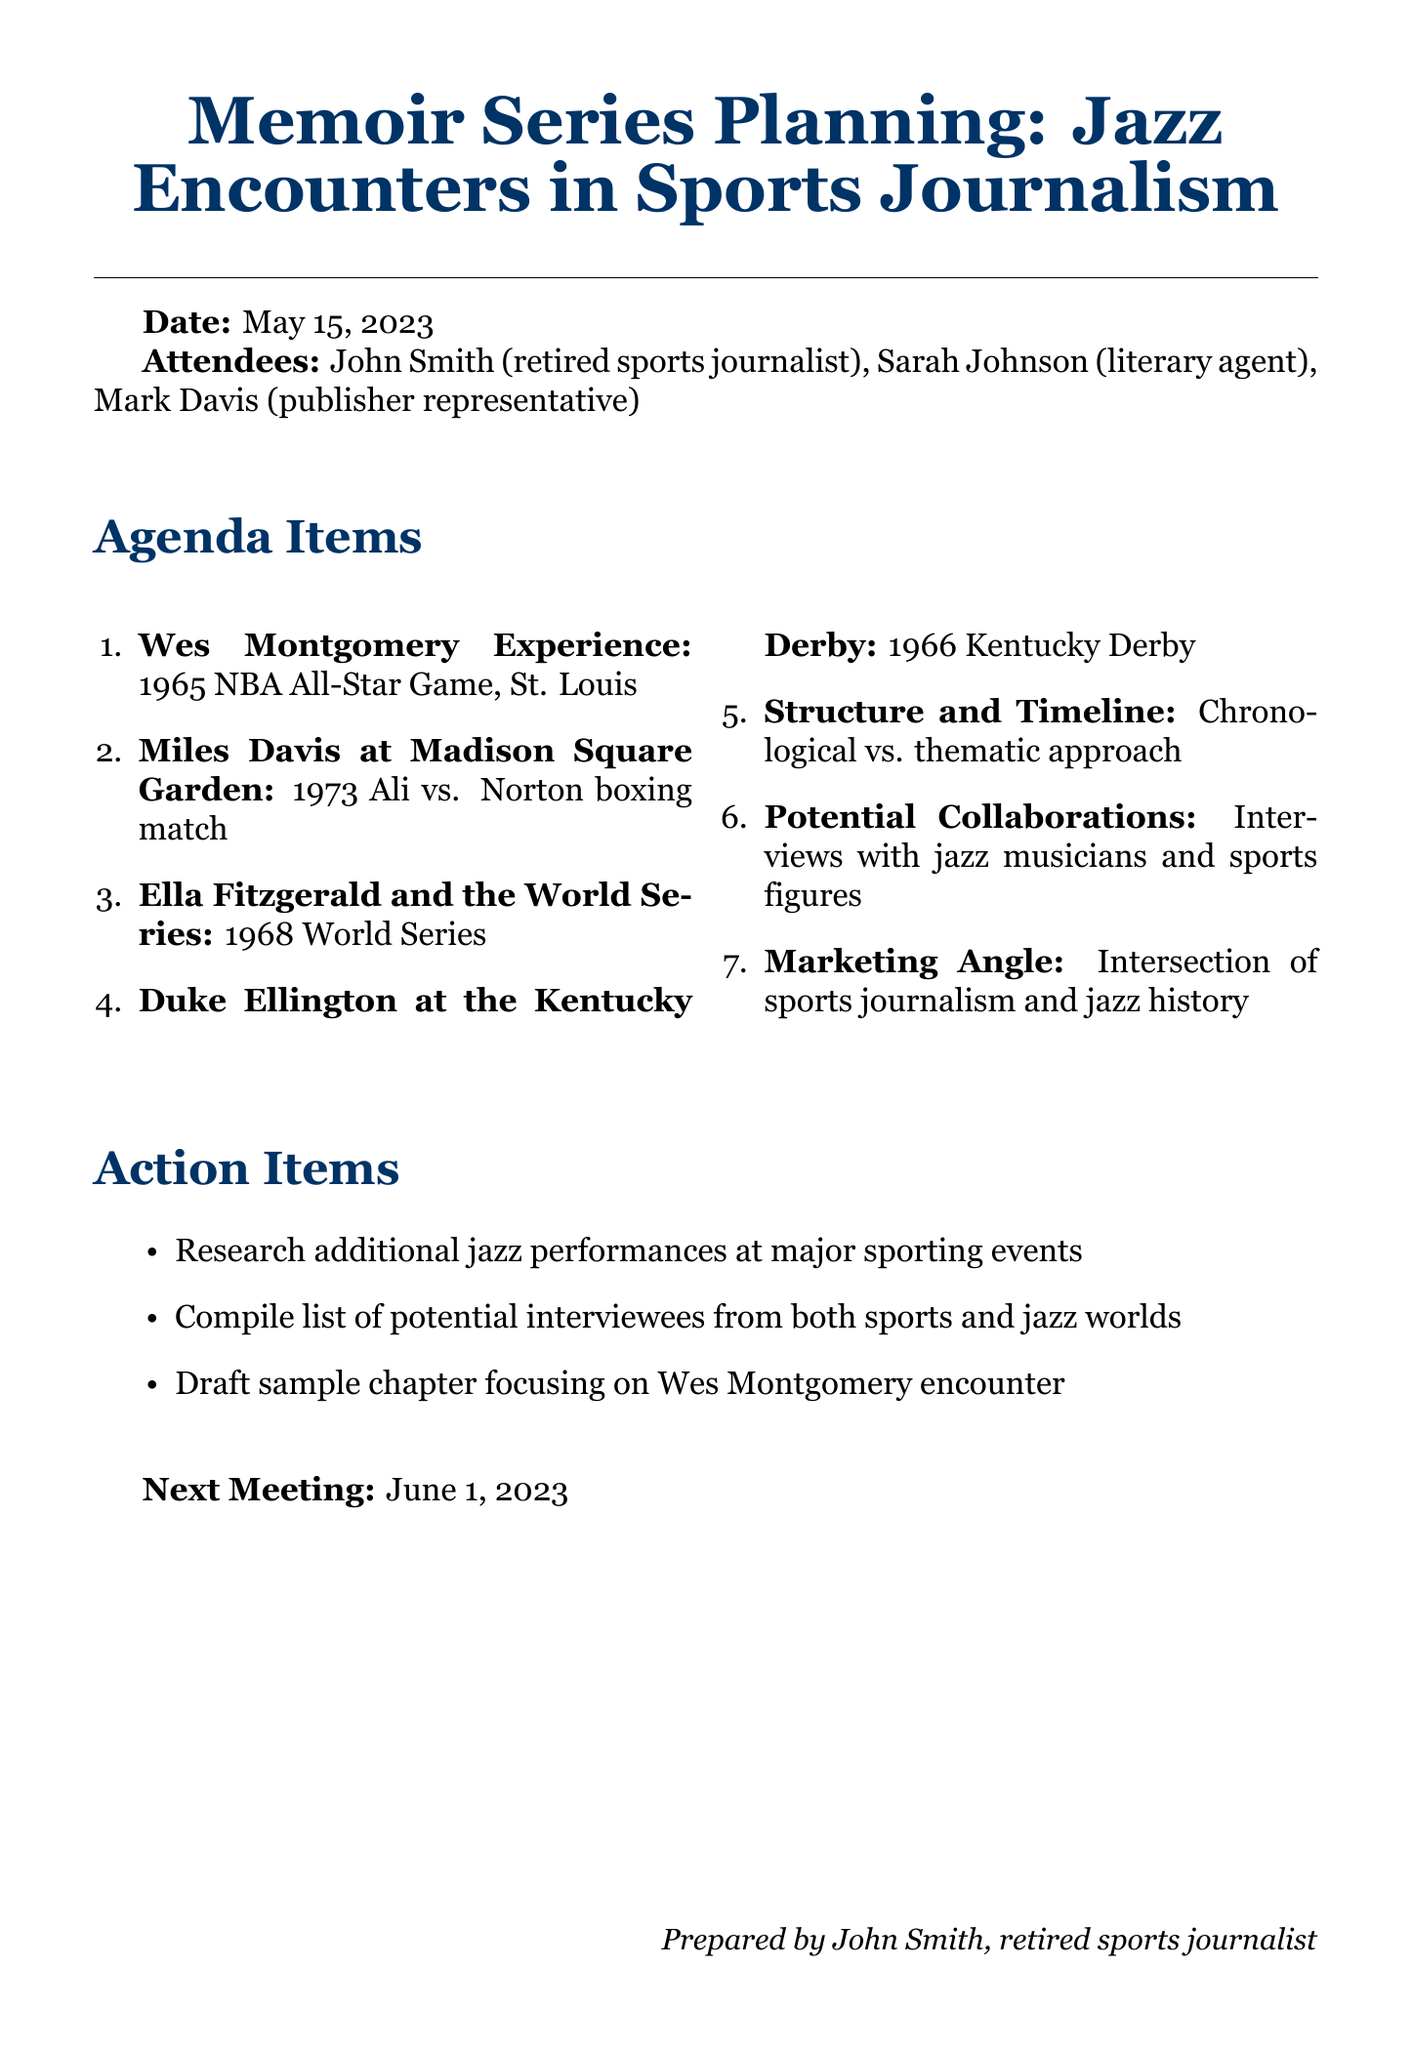what is the meeting title? The meeting title is stated at the start of the document and provides a clear overview of the topic discussed.
Answer: Memoir Series Planning: Jazz Encounters in Sports Journalism who attended the meeting? Attendees' names and titles are listed in the document, indicating who was present for the discussion.
Answer: John Smith, Sarah Johnson, Mark Davis what is the date of the meeting? The date is explicitly mentioned in the document, outlining when the meeting took place.
Answer: May 15, 2023 what is the first agenda item? The agenda items are listed in the document, with the first item specifically named.
Answer: Wes Montgomery Experience what year did Wes Montgomery perform at the NBA All-Star Game? The document details the event where Wes Montgomery performed, including the year of that performance.
Answer: 1965 what is one of the action items discussed? Action items are clearly outlined in the document, indicating tasks that need to be addressed following the meeting.
Answer: Research additional jazz performances at major sporting events when is the next meeting scheduled? The date for the next meeting is provided at the end of the document, indicating future plans.
Answer: June 1, 2023 how many action items were listed? The document lists the specific action items discussed, allowing for a count of how many were outlined.
Answer: Three what is the purpose of the marketing angle mentioned? The document explains the reasoning behind the marketing angle, highlighting its dual appeal.
Answer: Attract both music and sports enthusiasts 